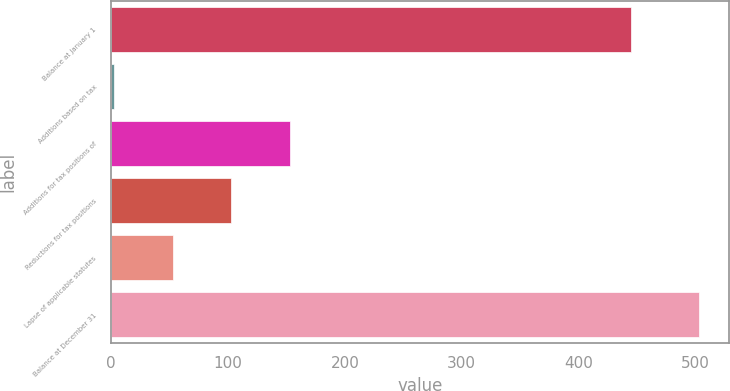<chart> <loc_0><loc_0><loc_500><loc_500><bar_chart><fcel>Balance at January 1<fcel>Additions based on tax<fcel>Additions for tax positions of<fcel>Reductions for tax positions<fcel>Lapse of applicable statutes<fcel>Balance at December 31<nl><fcel>445<fcel>3<fcel>153<fcel>103<fcel>53<fcel>503<nl></chart> 